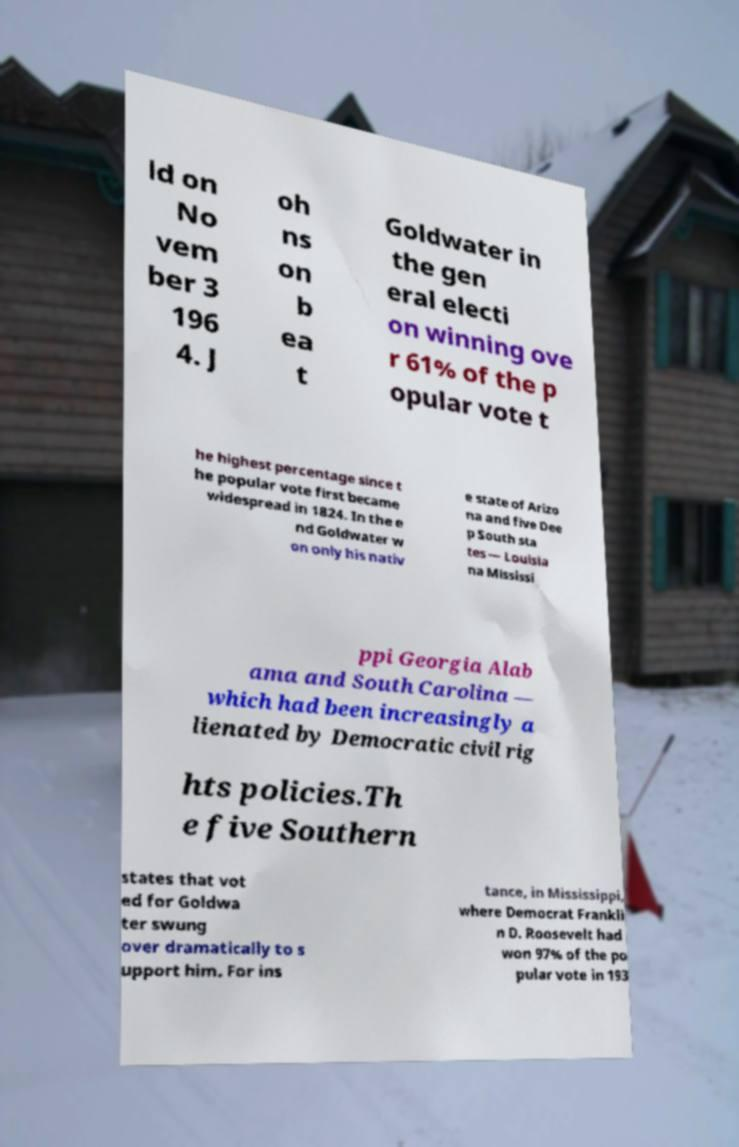What messages or text are displayed in this image? I need them in a readable, typed format. ld on No vem ber 3 196 4. J oh ns on b ea t Goldwater in the gen eral electi on winning ove r 61% of the p opular vote t he highest percentage since t he popular vote first became widespread in 1824. In the e nd Goldwater w on only his nativ e state of Arizo na and five Dee p South sta tes — Louisia na Mississi ppi Georgia Alab ama and South Carolina — which had been increasingly a lienated by Democratic civil rig hts policies.Th e five Southern states that vot ed for Goldwa ter swung over dramatically to s upport him. For ins tance, in Mississippi, where Democrat Frankli n D. Roosevelt had won 97% of the po pular vote in 193 